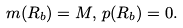<formula> <loc_0><loc_0><loc_500><loc_500>m ( R _ { b } ) = M , \, p ( R _ { b } ) = 0 .</formula> 